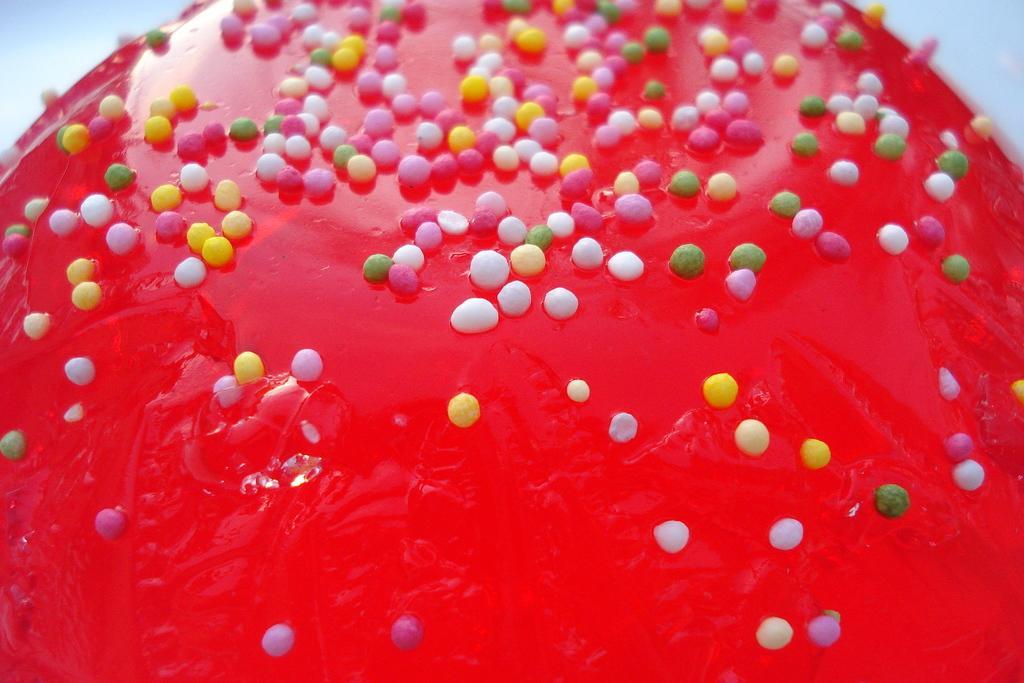How would you summarize this image in a sentence or two? In this picture I can see there is a red color candy and there are colorful sugar balls sprinkled on the candy. 